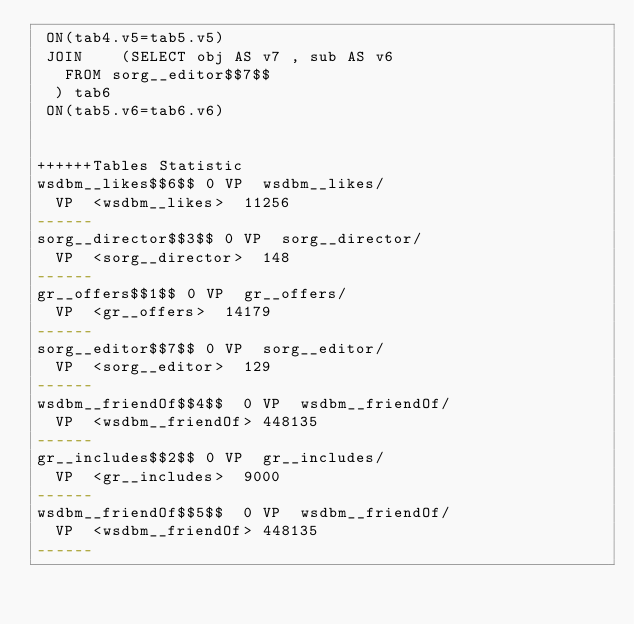Convert code to text. <code><loc_0><loc_0><loc_500><loc_500><_SQL_> ON(tab4.v5=tab5.v5)
 JOIN    (SELECT obj AS v7 , sub AS v6 
	 FROM sorg__editor$$7$$
	) tab6
 ON(tab5.v6=tab6.v6)


++++++Tables Statistic
wsdbm__likes$$6$$	0	VP	wsdbm__likes/
	VP	<wsdbm__likes>	11256
------
sorg__director$$3$$	0	VP	sorg__director/
	VP	<sorg__director>	148
------
gr__offers$$1$$	0	VP	gr__offers/
	VP	<gr__offers>	14179
------
sorg__editor$$7$$	0	VP	sorg__editor/
	VP	<sorg__editor>	129
------
wsdbm__friendOf$$4$$	0	VP	wsdbm__friendOf/
	VP	<wsdbm__friendOf>	448135
------
gr__includes$$2$$	0	VP	gr__includes/
	VP	<gr__includes>	9000
------
wsdbm__friendOf$$5$$	0	VP	wsdbm__friendOf/
	VP	<wsdbm__friendOf>	448135
------
</code> 